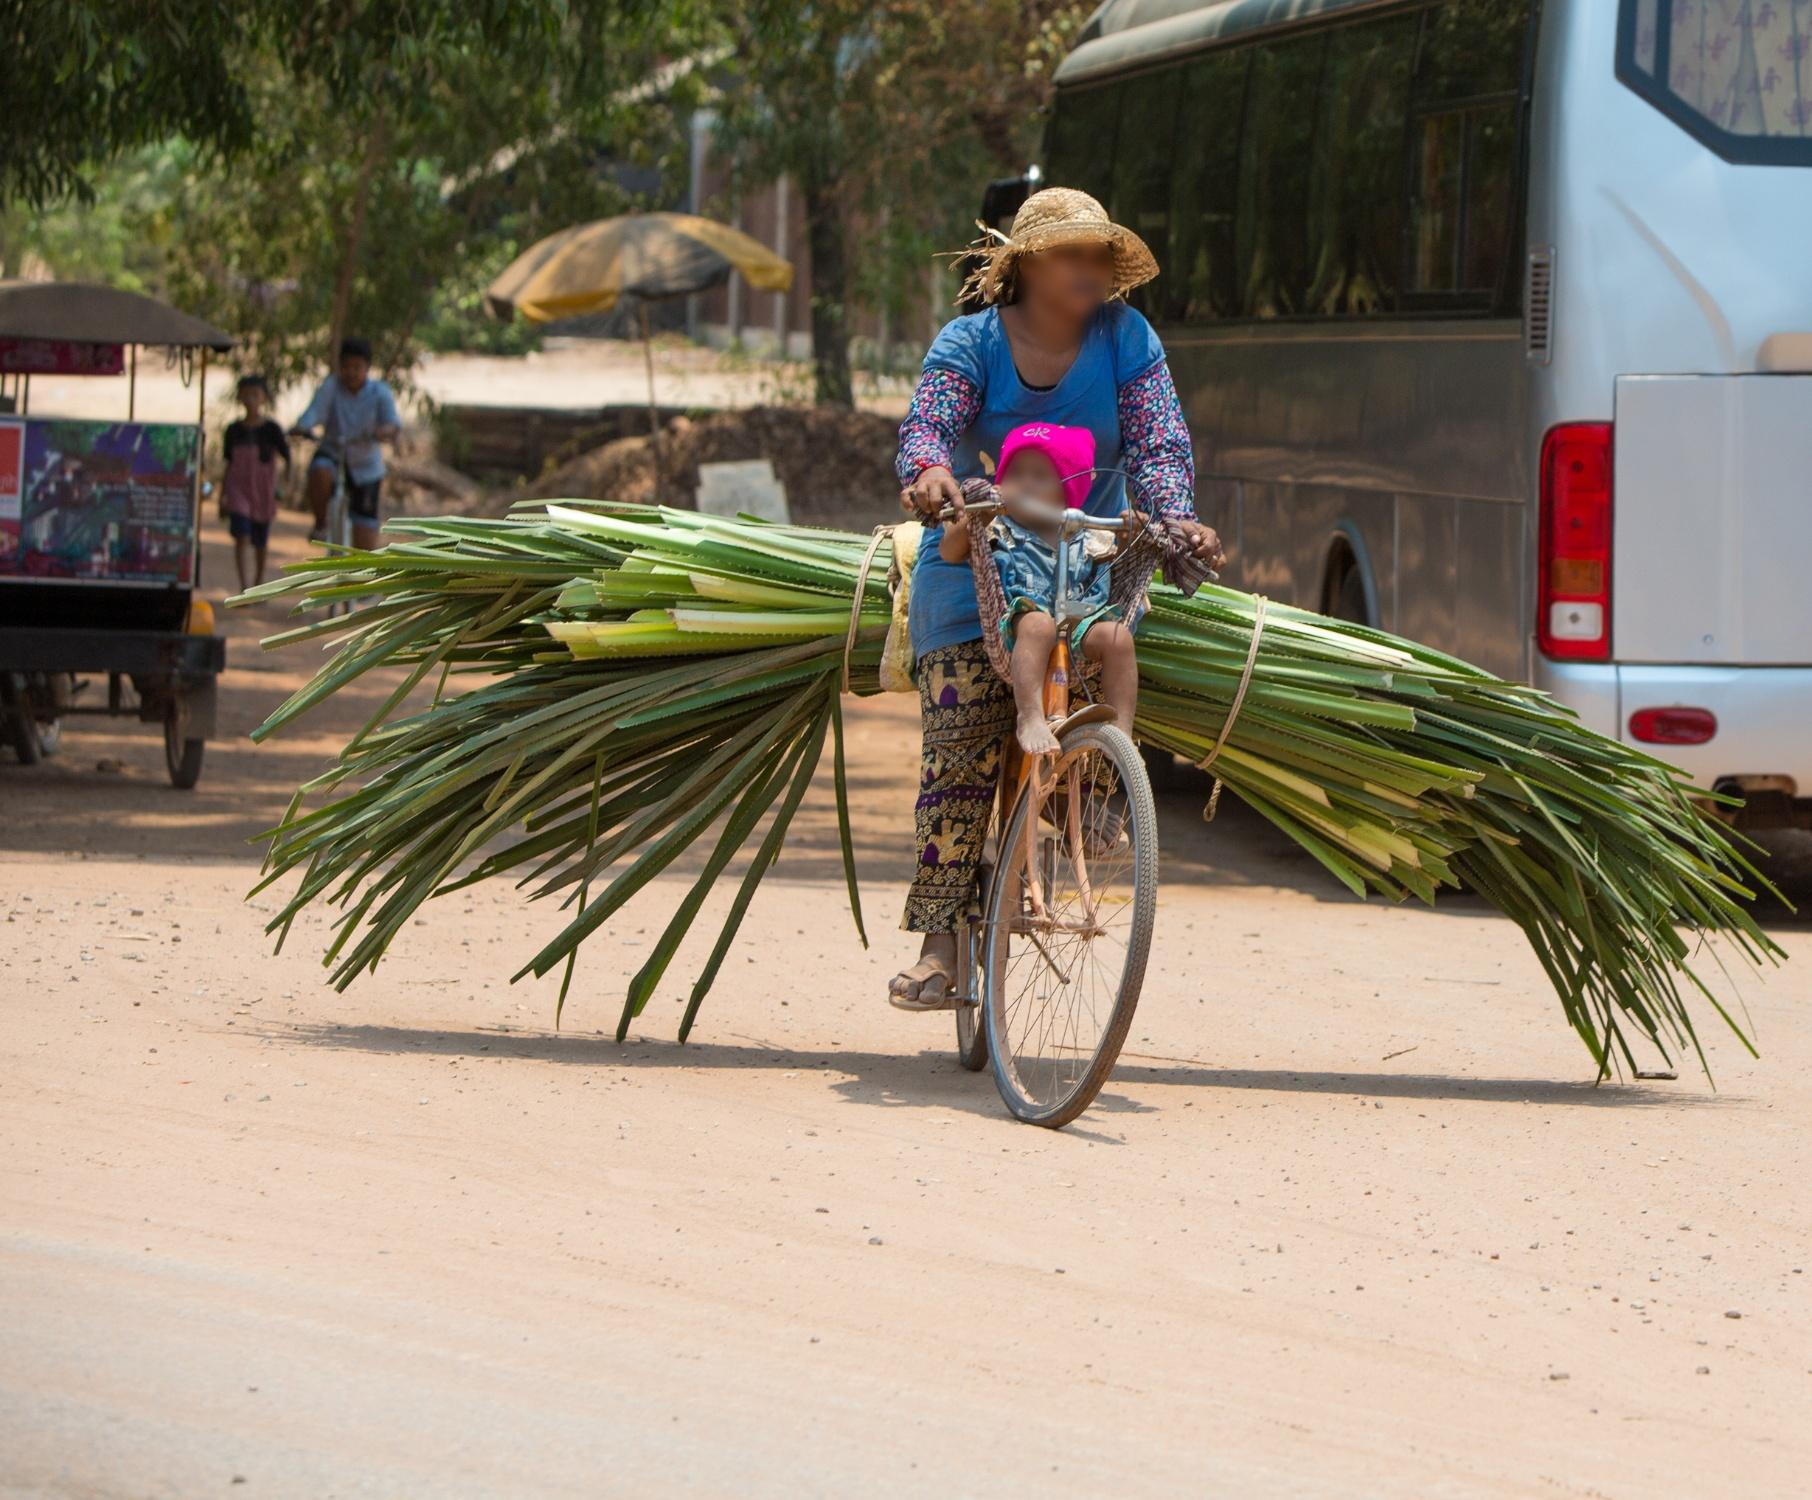What might be the daily routine of the woman in the image? The daily routine of the woman in the image likely begins early in the morning. She might start her day by gathering the green palm leaves from nearby fields or forests. Once collected, she carefully ties the leaves into large bundles, ensuring they are securely fastened to the back of her bicycle. After preparing her load, she begins her journey on the dirt road toward a local market or a designated area for delivering the leaves. Her day involves navigating the rural paths, interacting with local villagers, and balancing her work with any household responsibilities she may have. As the sun sets, she likely returns home, preparing for another day of labor, indicative of the hardworking and resilient spirit common in rural communities. What might be a brief summary of her interaction with the community? In her interaction with the community, the woman appears to be a dedicated and familiar figure. She might engage with locals, exchanging pleasantries and updated news while delivering her palm leaves. Her contribution through these materials, whether for crafts, building, or agricultural purposes, makes her an appreciated and integral part of the local economy and culture. 